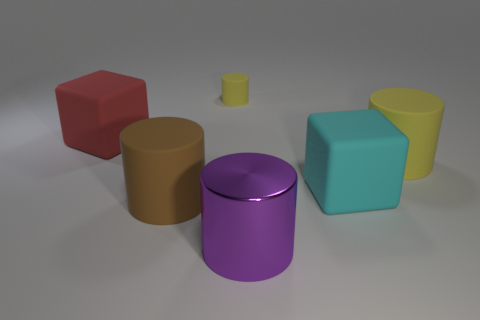What is the size of the matte cylinder that is the same color as the small matte object?
Keep it short and to the point. Large. Is there anything else that has the same material as the big purple object?
Your response must be concise. No. Is the material of the big cylinder behind the big cyan object the same as the big purple thing?
Offer a very short reply. No. What material is the big block that is behind the yellow matte thing that is right of the purple shiny thing?
Offer a very short reply. Rubber. The matte block that is on the right side of the big red block is what color?
Provide a succinct answer. Cyan. What is the size of the other block that is made of the same material as the big cyan block?
Provide a succinct answer. Large. How many large cyan rubber objects have the same shape as the large yellow thing?
Give a very brief answer. 0. There is a red object that is the same size as the brown rubber cylinder; what is it made of?
Provide a succinct answer. Rubber. Is there a yellow thing made of the same material as the large red block?
Your answer should be very brief. Yes. There is a big thing that is both to the left of the large yellow cylinder and right of the large metallic cylinder; what is its color?
Offer a terse response. Cyan. 